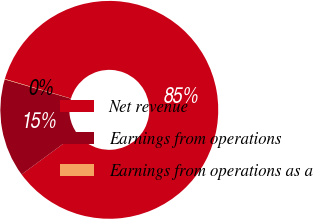Convert chart. <chart><loc_0><loc_0><loc_500><loc_500><pie_chart><fcel>Net revenue<fcel>Earnings from operations<fcel>Earnings from operations as a<nl><fcel>85.33%<fcel>14.61%<fcel>0.06%<nl></chart> 